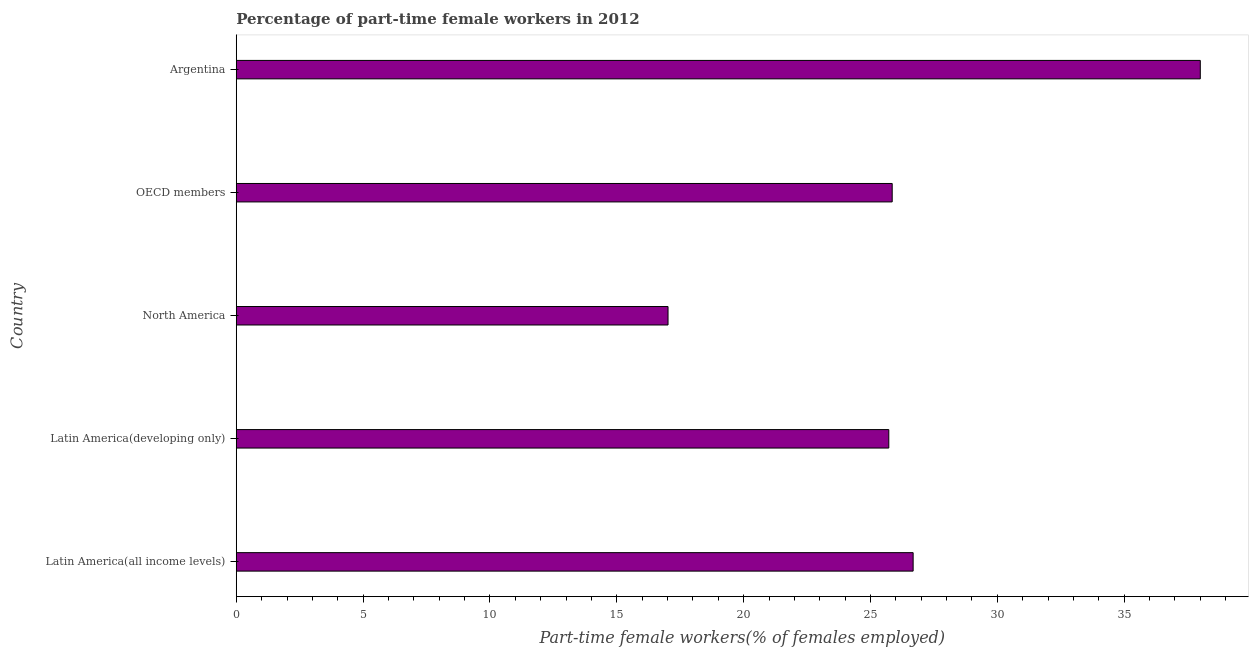What is the title of the graph?
Offer a terse response. Percentage of part-time female workers in 2012. What is the label or title of the X-axis?
Your response must be concise. Part-time female workers(% of females employed). What is the percentage of part-time female workers in OECD members?
Make the answer very short. 25.86. Across all countries, what is the minimum percentage of part-time female workers?
Ensure brevity in your answer.  17.02. In which country was the percentage of part-time female workers maximum?
Your answer should be very brief. Argentina. What is the sum of the percentage of part-time female workers?
Provide a succinct answer. 133.28. What is the difference between the percentage of part-time female workers in Latin America(all income levels) and North America?
Give a very brief answer. 9.66. What is the average percentage of part-time female workers per country?
Give a very brief answer. 26.66. What is the median percentage of part-time female workers?
Ensure brevity in your answer.  25.86. In how many countries, is the percentage of part-time female workers greater than 11 %?
Give a very brief answer. 5. What is the ratio of the percentage of part-time female workers in Argentina to that in Latin America(developing only)?
Your answer should be compact. 1.48. Is the difference between the percentage of part-time female workers in Latin America(all income levels) and OECD members greater than the difference between any two countries?
Make the answer very short. No. What is the difference between the highest and the second highest percentage of part-time female workers?
Provide a short and direct response. 11.32. Is the sum of the percentage of part-time female workers in Latin America(all income levels) and Latin America(developing only) greater than the maximum percentage of part-time female workers across all countries?
Keep it short and to the point. Yes. What is the difference between the highest and the lowest percentage of part-time female workers?
Your answer should be very brief. 20.98. How many bars are there?
Offer a very short reply. 5. Are all the bars in the graph horizontal?
Your answer should be very brief. Yes. What is the difference between two consecutive major ticks on the X-axis?
Make the answer very short. 5. Are the values on the major ticks of X-axis written in scientific E-notation?
Keep it short and to the point. No. What is the Part-time female workers(% of females employed) of Latin America(all income levels)?
Offer a very short reply. 26.68. What is the Part-time female workers(% of females employed) of Latin America(developing only)?
Provide a short and direct response. 25.72. What is the Part-time female workers(% of females employed) in North America?
Provide a succinct answer. 17.02. What is the Part-time female workers(% of females employed) in OECD members?
Provide a succinct answer. 25.86. What is the Part-time female workers(% of females employed) in Argentina?
Offer a terse response. 38. What is the difference between the Part-time female workers(% of females employed) in Latin America(all income levels) and Latin America(developing only)?
Offer a very short reply. 0.96. What is the difference between the Part-time female workers(% of females employed) in Latin America(all income levels) and North America?
Offer a terse response. 9.66. What is the difference between the Part-time female workers(% of females employed) in Latin America(all income levels) and OECD members?
Your answer should be compact. 0.83. What is the difference between the Part-time female workers(% of females employed) in Latin America(all income levels) and Argentina?
Keep it short and to the point. -11.32. What is the difference between the Part-time female workers(% of females employed) in Latin America(developing only) and North America?
Your answer should be very brief. 8.7. What is the difference between the Part-time female workers(% of females employed) in Latin America(developing only) and OECD members?
Keep it short and to the point. -0.13. What is the difference between the Part-time female workers(% of females employed) in Latin America(developing only) and Argentina?
Offer a very short reply. -12.28. What is the difference between the Part-time female workers(% of females employed) in North America and OECD members?
Your answer should be very brief. -8.84. What is the difference between the Part-time female workers(% of females employed) in North America and Argentina?
Provide a succinct answer. -20.98. What is the difference between the Part-time female workers(% of females employed) in OECD members and Argentina?
Offer a very short reply. -12.14. What is the ratio of the Part-time female workers(% of females employed) in Latin America(all income levels) to that in Latin America(developing only)?
Offer a very short reply. 1.04. What is the ratio of the Part-time female workers(% of females employed) in Latin America(all income levels) to that in North America?
Offer a terse response. 1.57. What is the ratio of the Part-time female workers(% of females employed) in Latin America(all income levels) to that in OECD members?
Provide a short and direct response. 1.03. What is the ratio of the Part-time female workers(% of females employed) in Latin America(all income levels) to that in Argentina?
Ensure brevity in your answer.  0.7. What is the ratio of the Part-time female workers(% of females employed) in Latin America(developing only) to that in North America?
Offer a very short reply. 1.51. What is the ratio of the Part-time female workers(% of females employed) in Latin America(developing only) to that in Argentina?
Your answer should be compact. 0.68. What is the ratio of the Part-time female workers(% of females employed) in North America to that in OECD members?
Keep it short and to the point. 0.66. What is the ratio of the Part-time female workers(% of females employed) in North America to that in Argentina?
Provide a succinct answer. 0.45. What is the ratio of the Part-time female workers(% of females employed) in OECD members to that in Argentina?
Give a very brief answer. 0.68. 